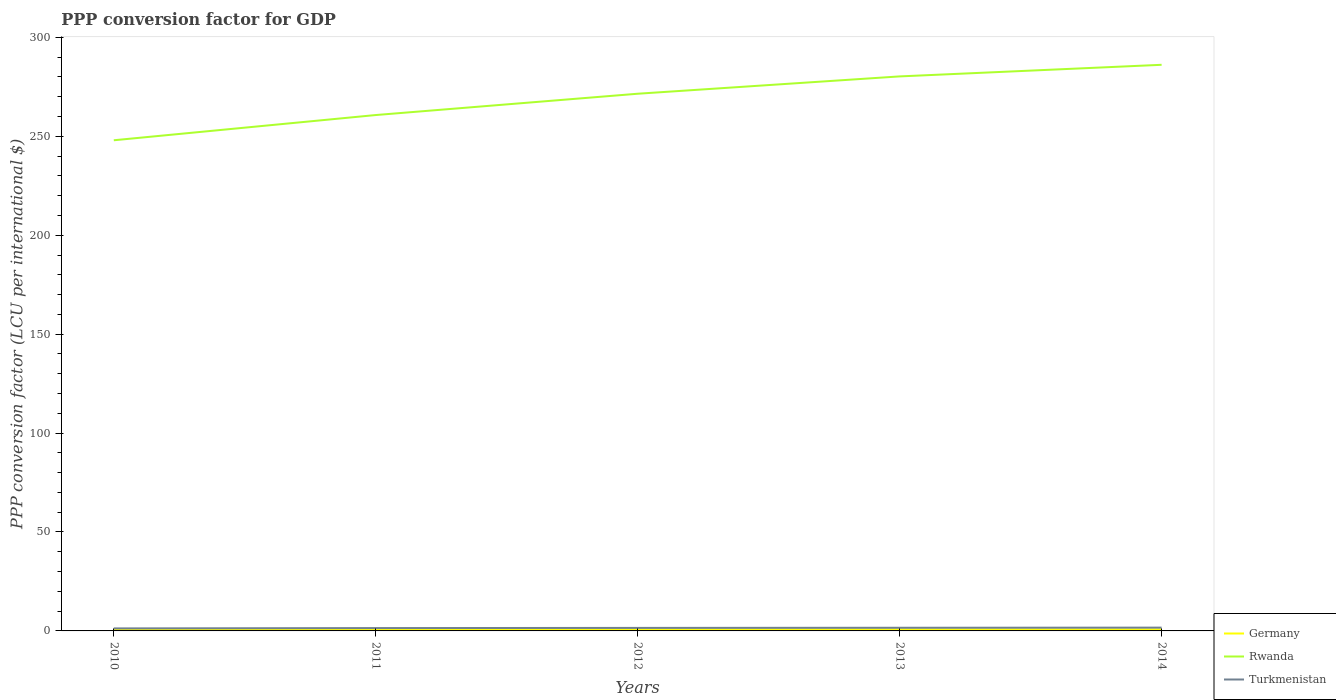How many different coloured lines are there?
Offer a terse response. 3. Does the line corresponding to Germany intersect with the line corresponding to Turkmenistan?
Provide a short and direct response. No. Across all years, what is the maximum PPP conversion factor for GDP in Germany?
Make the answer very short. 0.78. What is the total PPP conversion factor for GDP in Rwanda in the graph?
Your answer should be very brief. -25.39. What is the difference between the highest and the second highest PPP conversion factor for GDP in Rwanda?
Offer a terse response. 38.14. What is the difference between the highest and the lowest PPP conversion factor for GDP in Rwanda?
Your response must be concise. 3. Is the PPP conversion factor for GDP in Rwanda strictly greater than the PPP conversion factor for GDP in Turkmenistan over the years?
Keep it short and to the point. No. How many years are there in the graph?
Offer a terse response. 5. Are the values on the major ticks of Y-axis written in scientific E-notation?
Provide a succinct answer. No. Does the graph contain any zero values?
Give a very brief answer. No. Where does the legend appear in the graph?
Make the answer very short. Bottom right. What is the title of the graph?
Your response must be concise. PPP conversion factor for GDP. What is the label or title of the Y-axis?
Offer a very short reply. PPP conversion factor (LCU per international $). What is the PPP conversion factor (LCU per international $) of Germany in 2010?
Make the answer very short. 0.8. What is the PPP conversion factor (LCU per international $) of Rwanda in 2010?
Keep it short and to the point. 248. What is the PPP conversion factor (LCU per international $) of Turkmenistan in 2010?
Keep it short and to the point. 1.27. What is the PPP conversion factor (LCU per international $) in Germany in 2011?
Make the answer very short. 0.78. What is the PPP conversion factor (LCU per international $) of Rwanda in 2011?
Your answer should be compact. 260.75. What is the PPP conversion factor (LCU per international $) of Turkmenistan in 2011?
Offer a very short reply. 1.44. What is the PPP conversion factor (LCU per international $) in Germany in 2012?
Offer a very short reply. 0.79. What is the PPP conversion factor (LCU per international $) of Rwanda in 2012?
Make the answer very short. 271.52. What is the PPP conversion factor (LCU per international $) in Turkmenistan in 2012?
Offer a terse response. 1.53. What is the PPP conversion factor (LCU per international $) of Germany in 2013?
Your response must be concise. 0.79. What is the PPP conversion factor (LCU per international $) of Rwanda in 2013?
Your answer should be compact. 280.28. What is the PPP conversion factor (LCU per international $) of Turkmenistan in 2013?
Provide a short and direct response. 1.59. What is the PPP conversion factor (LCU per international $) of Germany in 2014?
Provide a succinct answer. 0.79. What is the PPP conversion factor (LCU per international $) of Rwanda in 2014?
Provide a short and direct response. 286.14. What is the PPP conversion factor (LCU per international $) of Turkmenistan in 2014?
Offer a terse response. 1.66. Across all years, what is the maximum PPP conversion factor (LCU per international $) in Germany?
Make the answer very short. 0.8. Across all years, what is the maximum PPP conversion factor (LCU per international $) of Rwanda?
Give a very brief answer. 286.14. Across all years, what is the maximum PPP conversion factor (LCU per international $) in Turkmenistan?
Offer a terse response. 1.66. Across all years, what is the minimum PPP conversion factor (LCU per international $) of Germany?
Your answer should be compact. 0.78. Across all years, what is the minimum PPP conversion factor (LCU per international $) of Rwanda?
Provide a succinct answer. 248. Across all years, what is the minimum PPP conversion factor (LCU per international $) of Turkmenistan?
Your answer should be compact. 1.27. What is the total PPP conversion factor (LCU per international $) of Germany in the graph?
Offer a very short reply. 3.95. What is the total PPP conversion factor (LCU per international $) of Rwanda in the graph?
Offer a very short reply. 1346.69. What is the total PPP conversion factor (LCU per international $) of Turkmenistan in the graph?
Offer a very short reply. 7.49. What is the difference between the PPP conversion factor (LCU per international $) of Germany in 2010 and that in 2011?
Your response must be concise. 0.01. What is the difference between the PPP conversion factor (LCU per international $) in Rwanda in 2010 and that in 2011?
Your answer should be compact. -12.75. What is the difference between the PPP conversion factor (LCU per international $) in Turkmenistan in 2010 and that in 2011?
Provide a succinct answer. -0.16. What is the difference between the PPP conversion factor (LCU per international $) of Germany in 2010 and that in 2012?
Make the answer very short. 0.01. What is the difference between the PPP conversion factor (LCU per international $) in Rwanda in 2010 and that in 2012?
Make the answer very short. -23.52. What is the difference between the PPP conversion factor (LCU per international $) of Turkmenistan in 2010 and that in 2012?
Your answer should be compact. -0.25. What is the difference between the PPP conversion factor (LCU per international $) in Germany in 2010 and that in 2013?
Your answer should be very brief. 0. What is the difference between the PPP conversion factor (LCU per international $) of Rwanda in 2010 and that in 2013?
Ensure brevity in your answer.  -32.28. What is the difference between the PPP conversion factor (LCU per international $) in Turkmenistan in 2010 and that in 2013?
Ensure brevity in your answer.  -0.32. What is the difference between the PPP conversion factor (LCU per international $) in Germany in 2010 and that in 2014?
Provide a succinct answer. 0.01. What is the difference between the PPP conversion factor (LCU per international $) in Rwanda in 2010 and that in 2014?
Give a very brief answer. -38.14. What is the difference between the PPP conversion factor (LCU per international $) in Turkmenistan in 2010 and that in 2014?
Keep it short and to the point. -0.39. What is the difference between the PPP conversion factor (LCU per international $) of Germany in 2011 and that in 2012?
Make the answer very short. -0. What is the difference between the PPP conversion factor (LCU per international $) in Rwanda in 2011 and that in 2012?
Give a very brief answer. -10.77. What is the difference between the PPP conversion factor (LCU per international $) in Turkmenistan in 2011 and that in 2012?
Offer a terse response. -0.09. What is the difference between the PPP conversion factor (LCU per international $) of Germany in 2011 and that in 2013?
Your response must be concise. -0.01. What is the difference between the PPP conversion factor (LCU per international $) of Rwanda in 2011 and that in 2013?
Give a very brief answer. -19.53. What is the difference between the PPP conversion factor (LCU per international $) in Turkmenistan in 2011 and that in 2013?
Keep it short and to the point. -0.16. What is the difference between the PPP conversion factor (LCU per international $) of Germany in 2011 and that in 2014?
Your response must be concise. -0. What is the difference between the PPP conversion factor (LCU per international $) of Rwanda in 2011 and that in 2014?
Offer a very short reply. -25.39. What is the difference between the PPP conversion factor (LCU per international $) in Turkmenistan in 2011 and that in 2014?
Your answer should be very brief. -0.23. What is the difference between the PPP conversion factor (LCU per international $) in Germany in 2012 and that in 2013?
Ensure brevity in your answer.  -0.01. What is the difference between the PPP conversion factor (LCU per international $) of Rwanda in 2012 and that in 2013?
Offer a very short reply. -8.76. What is the difference between the PPP conversion factor (LCU per international $) of Turkmenistan in 2012 and that in 2013?
Your answer should be very brief. -0.07. What is the difference between the PPP conversion factor (LCU per international $) in Germany in 2012 and that in 2014?
Offer a very short reply. -0. What is the difference between the PPP conversion factor (LCU per international $) in Rwanda in 2012 and that in 2014?
Provide a succinct answer. -14.62. What is the difference between the PPP conversion factor (LCU per international $) in Turkmenistan in 2012 and that in 2014?
Provide a succinct answer. -0.14. What is the difference between the PPP conversion factor (LCU per international $) of Germany in 2013 and that in 2014?
Make the answer very short. 0.01. What is the difference between the PPP conversion factor (LCU per international $) of Rwanda in 2013 and that in 2014?
Provide a succinct answer. -5.86. What is the difference between the PPP conversion factor (LCU per international $) of Turkmenistan in 2013 and that in 2014?
Your answer should be very brief. -0.07. What is the difference between the PPP conversion factor (LCU per international $) of Germany in 2010 and the PPP conversion factor (LCU per international $) of Rwanda in 2011?
Offer a very short reply. -259.95. What is the difference between the PPP conversion factor (LCU per international $) in Germany in 2010 and the PPP conversion factor (LCU per international $) in Turkmenistan in 2011?
Offer a terse response. -0.64. What is the difference between the PPP conversion factor (LCU per international $) of Rwanda in 2010 and the PPP conversion factor (LCU per international $) of Turkmenistan in 2011?
Offer a very short reply. 246.56. What is the difference between the PPP conversion factor (LCU per international $) in Germany in 2010 and the PPP conversion factor (LCU per international $) in Rwanda in 2012?
Provide a short and direct response. -270.72. What is the difference between the PPP conversion factor (LCU per international $) in Germany in 2010 and the PPP conversion factor (LCU per international $) in Turkmenistan in 2012?
Keep it short and to the point. -0.73. What is the difference between the PPP conversion factor (LCU per international $) of Rwanda in 2010 and the PPP conversion factor (LCU per international $) of Turkmenistan in 2012?
Your answer should be very brief. 246.47. What is the difference between the PPP conversion factor (LCU per international $) in Germany in 2010 and the PPP conversion factor (LCU per international $) in Rwanda in 2013?
Ensure brevity in your answer.  -279.49. What is the difference between the PPP conversion factor (LCU per international $) in Germany in 2010 and the PPP conversion factor (LCU per international $) in Turkmenistan in 2013?
Offer a very short reply. -0.8. What is the difference between the PPP conversion factor (LCU per international $) in Rwanda in 2010 and the PPP conversion factor (LCU per international $) in Turkmenistan in 2013?
Your response must be concise. 246.41. What is the difference between the PPP conversion factor (LCU per international $) in Germany in 2010 and the PPP conversion factor (LCU per international $) in Rwanda in 2014?
Give a very brief answer. -285.35. What is the difference between the PPP conversion factor (LCU per international $) of Germany in 2010 and the PPP conversion factor (LCU per international $) of Turkmenistan in 2014?
Keep it short and to the point. -0.87. What is the difference between the PPP conversion factor (LCU per international $) of Rwanda in 2010 and the PPP conversion factor (LCU per international $) of Turkmenistan in 2014?
Give a very brief answer. 246.34. What is the difference between the PPP conversion factor (LCU per international $) in Germany in 2011 and the PPP conversion factor (LCU per international $) in Rwanda in 2012?
Your answer should be compact. -270.74. What is the difference between the PPP conversion factor (LCU per international $) in Germany in 2011 and the PPP conversion factor (LCU per international $) in Turkmenistan in 2012?
Offer a very short reply. -0.74. What is the difference between the PPP conversion factor (LCU per international $) in Rwanda in 2011 and the PPP conversion factor (LCU per international $) in Turkmenistan in 2012?
Make the answer very short. 259.22. What is the difference between the PPP conversion factor (LCU per international $) of Germany in 2011 and the PPP conversion factor (LCU per international $) of Rwanda in 2013?
Your answer should be compact. -279.5. What is the difference between the PPP conversion factor (LCU per international $) of Germany in 2011 and the PPP conversion factor (LCU per international $) of Turkmenistan in 2013?
Your answer should be compact. -0.81. What is the difference between the PPP conversion factor (LCU per international $) in Rwanda in 2011 and the PPP conversion factor (LCU per international $) in Turkmenistan in 2013?
Provide a short and direct response. 259.16. What is the difference between the PPP conversion factor (LCU per international $) in Germany in 2011 and the PPP conversion factor (LCU per international $) in Rwanda in 2014?
Offer a terse response. -285.36. What is the difference between the PPP conversion factor (LCU per international $) in Germany in 2011 and the PPP conversion factor (LCU per international $) in Turkmenistan in 2014?
Offer a terse response. -0.88. What is the difference between the PPP conversion factor (LCU per international $) in Rwanda in 2011 and the PPP conversion factor (LCU per international $) in Turkmenistan in 2014?
Offer a very short reply. 259.09. What is the difference between the PPP conversion factor (LCU per international $) of Germany in 2012 and the PPP conversion factor (LCU per international $) of Rwanda in 2013?
Provide a succinct answer. -279.5. What is the difference between the PPP conversion factor (LCU per international $) in Germany in 2012 and the PPP conversion factor (LCU per international $) in Turkmenistan in 2013?
Your response must be concise. -0.81. What is the difference between the PPP conversion factor (LCU per international $) of Rwanda in 2012 and the PPP conversion factor (LCU per international $) of Turkmenistan in 2013?
Your response must be concise. 269.93. What is the difference between the PPP conversion factor (LCU per international $) in Germany in 2012 and the PPP conversion factor (LCU per international $) in Rwanda in 2014?
Keep it short and to the point. -285.36. What is the difference between the PPP conversion factor (LCU per international $) in Germany in 2012 and the PPP conversion factor (LCU per international $) in Turkmenistan in 2014?
Give a very brief answer. -0.88. What is the difference between the PPP conversion factor (LCU per international $) in Rwanda in 2012 and the PPP conversion factor (LCU per international $) in Turkmenistan in 2014?
Your answer should be very brief. 269.86. What is the difference between the PPP conversion factor (LCU per international $) in Germany in 2013 and the PPP conversion factor (LCU per international $) in Rwanda in 2014?
Ensure brevity in your answer.  -285.35. What is the difference between the PPP conversion factor (LCU per international $) of Germany in 2013 and the PPP conversion factor (LCU per international $) of Turkmenistan in 2014?
Provide a succinct answer. -0.87. What is the difference between the PPP conversion factor (LCU per international $) in Rwanda in 2013 and the PPP conversion factor (LCU per international $) in Turkmenistan in 2014?
Give a very brief answer. 278.62. What is the average PPP conversion factor (LCU per international $) of Germany per year?
Provide a succinct answer. 0.79. What is the average PPP conversion factor (LCU per international $) in Rwanda per year?
Your answer should be very brief. 269.34. What is the average PPP conversion factor (LCU per international $) of Turkmenistan per year?
Provide a short and direct response. 1.5. In the year 2010, what is the difference between the PPP conversion factor (LCU per international $) in Germany and PPP conversion factor (LCU per international $) in Rwanda?
Keep it short and to the point. -247.2. In the year 2010, what is the difference between the PPP conversion factor (LCU per international $) in Germany and PPP conversion factor (LCU per international $) in Turkmenistan?
Keep it short and to the point. -0.48. In the year 2010, what is the difference between the PPP conversion factor (LCU per international $) of Rwanda and PPP conversion factor (LCU per international $) of Turkmenistan?
Your answer should be very brief. 246.73. In the year 2011, what is the difference between the PPP conversion factor (LCU per international $) in Germany and PPP conversion factor (LCU per international $) in Rwanda?
Provide a succinct answer. -259.97. In the year 2011, what is the difference between the PPP conversion factor (LCU per international $) of Germany and PPP conversion factor (LCU per international $) of Turkmenistan?
Ensure brevity in your answer.  -0.65. In the year 2011, what is the difference between the PPP conversion factor (LCU per international $) in Rwanda and PPP conversion factor (LCU per international $) in Turkmenistan?
Provide a succinct answer. 259.31. In the year 2012, what is the difference between the PPP conversion factor (LCU per international $) of Germany and PPP conversion factor (LCU per international $) of Rwanda?
Offer a very short reply. -270.73. In the year 2012, what is the difference between the PPP conversion factor (LCU per international $) in Germany and PPP conversion factor (LCU per international $) in Turkmenistan?
Your response must be concise. -0.74. In the year 2012, what is the difference between the PPP conversion factor (LCU per international $) in Rwanda and PPP conversion factor (LCU per international $) in Turkmenistan?
Your answer should be compact. 269.99. In the year 2013, what is the difference between the PPP conversion factor (LCU per international $) of Germany and PPP conversion factor (LCU per international $) of Rwanda?
Offer a very short reply. -279.49. In the year 2013, what is the difference between the PPP conversion factor (LCU per international $) of Germany and PPP conversion factor (LCU per international $) of Turkmenistan?
Offer a very short reply. -0.8. In the year 2013, what is the difference between the PPP conversion factor (LCU per international $) of Rwanda and PPP conversion factor (LCU per international $) of Turkmenistan?
Your answer should be compact. 278.69. In the year 2014, what is the difference between the PPP conversion factor (LCU per international $) of Germany and PPP conversion factor (LCU per international $) of Rwanda?
Provide a succinct answer. -285.36. In the year 2014, what is the difference between the PPP conversion factor (LCU per international $) of Germany and PPP conversion factor (LCU per international $) of Turkmenistan?
Give a very brief answer. -0.88. In the year 2014, what is the difference between the PPP conversion factor (LCU per international $) in Rwanda and PPP conversion factor (LCU per international $) in Turkmenistan?
Provide a short and direct response. 284.48. What is the ratio of the PPP conversion factor (LCU per international $) in Germany in 2010 to that in 2011?
Keep it short and to the point. 1.02. What is the ratio of the PPP conversion factor (LCU per international $) in Rwanda in 2010 to that in 2011?
Give a very brief answer. 0.95. What is the ratio of the PPP conversion factor (LCU per international $) of Turkmenistan in 2010 to that in 2011?
Your response must be concise. 0.89. What is the ratio of the PPP conversion factor (LCU per international $) of Germany in 2010 to that in 2012?
Offer a terse response. 1.01. What is the ratio of the PPP conversion factor (LCU per international $) of Rwanda in 2010 to that in 2012?
Offer a very short reply. 0.91. What is the ratio of the PPP conversion factor (LCU per international $) of Turkmenistan in 2010 to that in 2012?
Provide a succinct answer. 0.83. What is the ratio of the PPP conversion factor (LCU per international $) in Germany in 2010 to that in 2013?
Ensure brevity in your answer.  1. What is the ratio of the PPP conversion factor (LCU per international $) of Rwanda in 2010 to that in 2013?
Keep it short and to the point. 0.88. What is the ratio of the PPP conversion factor (LCU per international $) in Turkmenistan in 2010 to that in 2013?
Make the answer very short. 0.8. What is the ratio of the PPP conversion factor (LCU per international $) of Germany in 2010 to that in 2014?
Give a very brief answer. 1.01. What is the ratio of the PPP conversion factor (LCU per international $) in Rwanda in 2010 to that in 2014?
Ensure brevity in your answer.  0.87. What is the ratio of the PPP conversion factor (LCU per international $) of Turkmenistan in 2010 to that in 2014?
Offer a very short reply. 0.77. What is the ratio of the PPP conversion factor (LCU per international $) in Rwanda in 2011 to that in 2012?
Ensure brevity in your answer.  0.96. What is the ratio of the PPP conversion factor (LCU per international $) of Turkmenistan in 2011 to that in 2012?
Make the answer very short. 0.94. What is the ratio of the PPP conversion factor (LCU per international $) of Germany in 2011 to that in 2013?
Ensure brevity in your answer.  0.99. What is the ratio of the PPP conversion factor (LCU per international $) in Rwanda in 2011 to that in 2013?
Your answer should be very brief. 0.93. What is the ratio of the PPP conversion factor (LCU per international $) of Turkmenistan in 2011 to that in 2013?
Give a very brief answer. 0.9. What is the ratio of the PPP conversion factor (LCU per international $) in Rwanda in 2011 to that in 2014?
Offer a very short reply. 0.91. What is the ratio of the PPP conversion factor (LCU per international $) of Turkmenistan in 2011 to that in 2014?
Your answer should be very brief. 0.86. What is the ratio of the PPP conversion factor (LCU per international $) of Rwanda in 2012 to that in 2013?
Your answer should be compact. 0.97. What is the ratio of the PPP conversion factor (LCU per international $) of Turkmenistan in 2012 to that in 2013?
Offer a very short reply. 0.96. What is the ratio of the PPP conversion factor (LCU per international $) of Rwanda in 2012 to that in 2014?
Keep it short and to the point. 0.95. What is the ratio of the PPP conversion factor (LCU per international $) in Turkmenistan in 2012 to that in 2014?
Your answer should be very brief. 0.92. What is the ratio of the PPP conversion factor (LCU per international $) in Germany in 2013 to that in 2014?
Your answer should be compact. 1.01. What is the ratio of the PPP conversion factor (LCU per international $) in Rwanda in 2013 to that in 2014?
Make the answer very short. 0.98. What is the ratio of the PPP conversion factor (LCU per international $) of Turkmenistan in 2013 to that in 2014?
Your response must be concise. 0.96. What is the difference between the highest and the second highest PPP conversion factor (LCU per international $) in Germany?
Your answer should be compact. 0. What is the difference between the highest and the second highest PPP conversion factor (LCU per international $) of Rwanda?
Keep it short and to the point. 5.86. What is the difference between the highest and the second highest PPP conversion factor (LCU per international $) in Turkmenistan?
Keep it short and to the point. 0.07. What is the difference between the highest and the lowest PPP conversion factor (LCU per international $) of Germany?
Provide a succinct answer. 0.01. What is the difference between the highest and the lowest PPP conversion factor (LCU per international $) of Rwanda?
Offer a terse response. 38.14. What is the difference between the highest and the lowest PPP conversion factor (LCU per international $) in Turkmenistan?
Give a very brief answer. 0.39. 